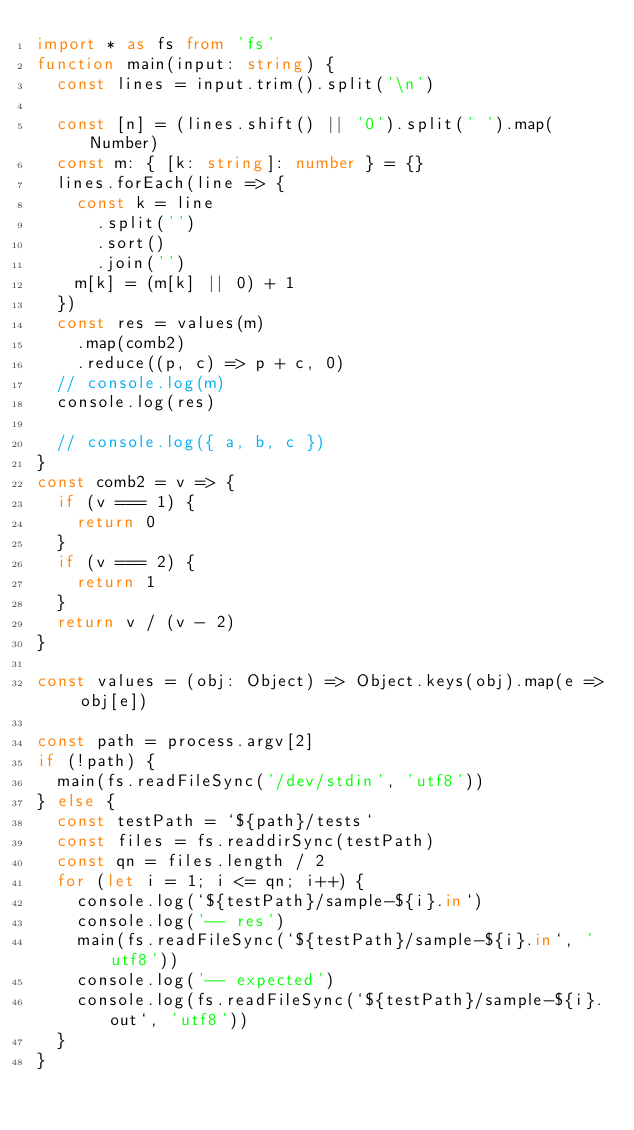Convert code to text. <code><loc_0><loc_0><loc_500><loc_500><_TypeScript_>import * as fs from 'fs'
function main(input: string) {
  const lines = input.trim().split('\n')

  const [n] = (lines.shift() || '0').split(' ').map(Number)
  const m: { [k: string]: number } = {}
  lines.forEach(line => {
    const k = line
      .split('')
      .sort()
      .join('')
    m[k] = (m[k] || 0) + 1
  })
  const res = values(m)
    .map(comb2)
    .reduce((p, c) => p + c, 0)
  // console.log(m)
  console.log(res)

  // console.log({ a, b, c })
}
const comb2 = v => {
  if (v === 1) {
    return 0
  }
  if (v === 2) {
    return 1
  }
  return v / (v - 2)
}

const values = (obj: Object) => Object.keys(obj).map(e => obj[e])

const path = process.argv[2]
if (!path) {
  main(fs.readFileSync('/dev/stdin', 'utf8'))
} else {
  const testPath = `${path}/tests`
  const files = fs.readdirSync(testPath)
  const qn = files.length / 2
  for (let i = 1; i <= qn; i++) {
    console.log(`${testPath}/sample-${i}.in`)
    console.log('-- res')
    main(fs.readFileSync(`${testPath}/sample-${i}.in`, 'utf8'))
    console.log('-- expected')
    console.log(fs.readFileSync(`${testPath}/sample-${i}.out`, 'utf8'))
  }
}
</code> 